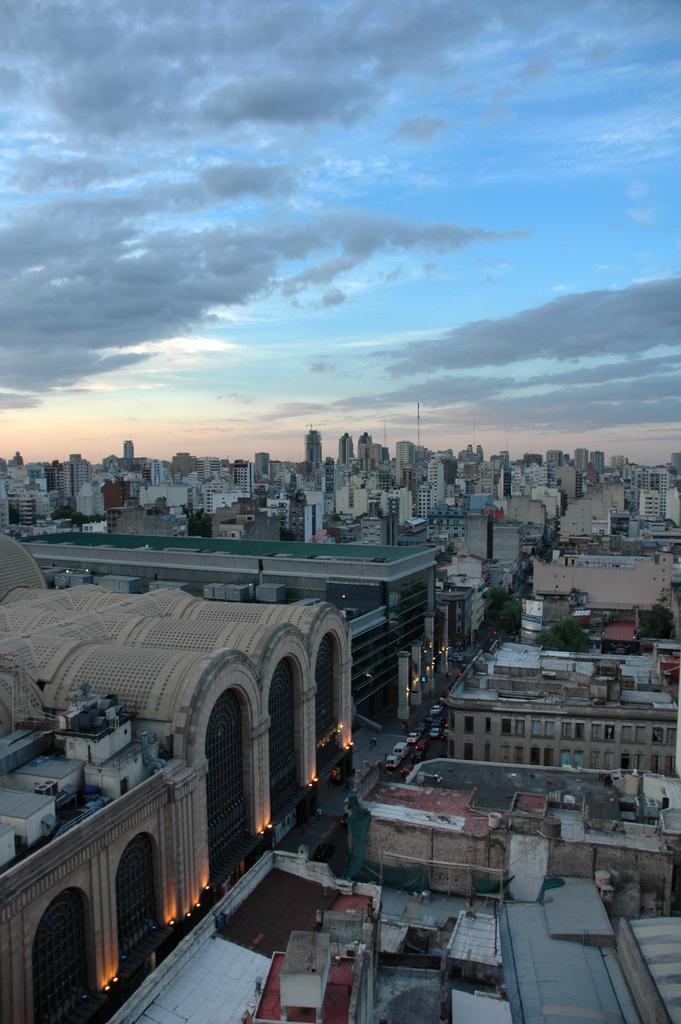Could you give a brief overview of what you see in this image? This is the view of the city. These are the buildings. I can see a road with the vehicles. These are the clouds in the sky. 